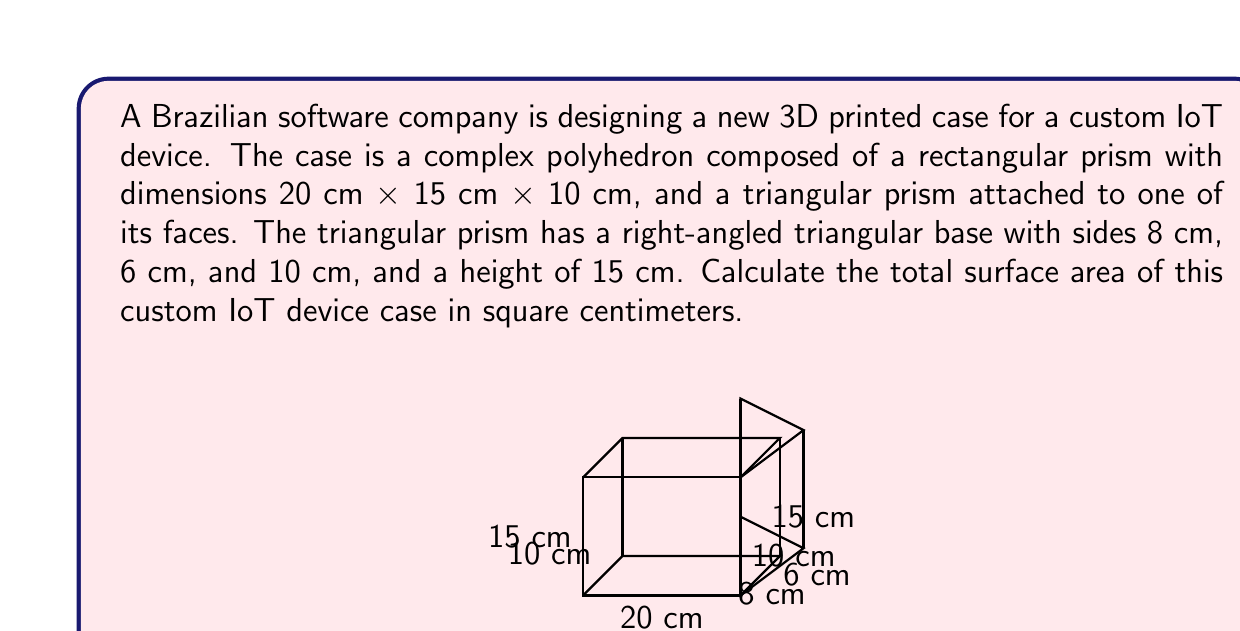Provide a solution to this math problem. To solve this problem, we need to calculate the surface area of each part of the polyhedron and sum them up. Let's break it down step by step:

1. Surface area of the rectangular prism:
   - Front and back faces: $2 \times (20 \times 15) = 600$ cm²
   - Top and bottom faces: $2 \times (20 \times 10) = 400$ cm²
   - Left and right faces: $2 \times (15 \times 10) = 300$ cm²
   Subtotal: $600 + 400 + 300 = 1300$ cm²

2. Surface area of the triangular prism:
   - Triangular bases: $2 \times \frac{1}{2} \times 8 \times 6 = 48$ cm²
   - Rectangular face (hypotenuse): $10 \times 15 = 150$ cm²
   - Rectangular face (height): $8 \times 15 = 120$ cm²
   - Rectangular face (base): $6 \times 15 = 90$ cm²
   Subtotal: $48 + 150 + 120 + 90 = 408$ cm²

3. Shared face between rectangular and triangular prisms:
   We need to subtract this face as it's counted twice: $10 \times 15 = 150$ cm²

Now, we can calculate the total surface area:

$$\text{Total Surface Area} = 1300 + 408 - 150 = 1558 \text{ cm}^2$$

This calculation accounts for all exposed surfaces of the complex polyhedron, including the rectangular prism and the attached triangular prism, while avoiding double-counting the shared face.
Answer: $1558 \text{ cm}^2$ 